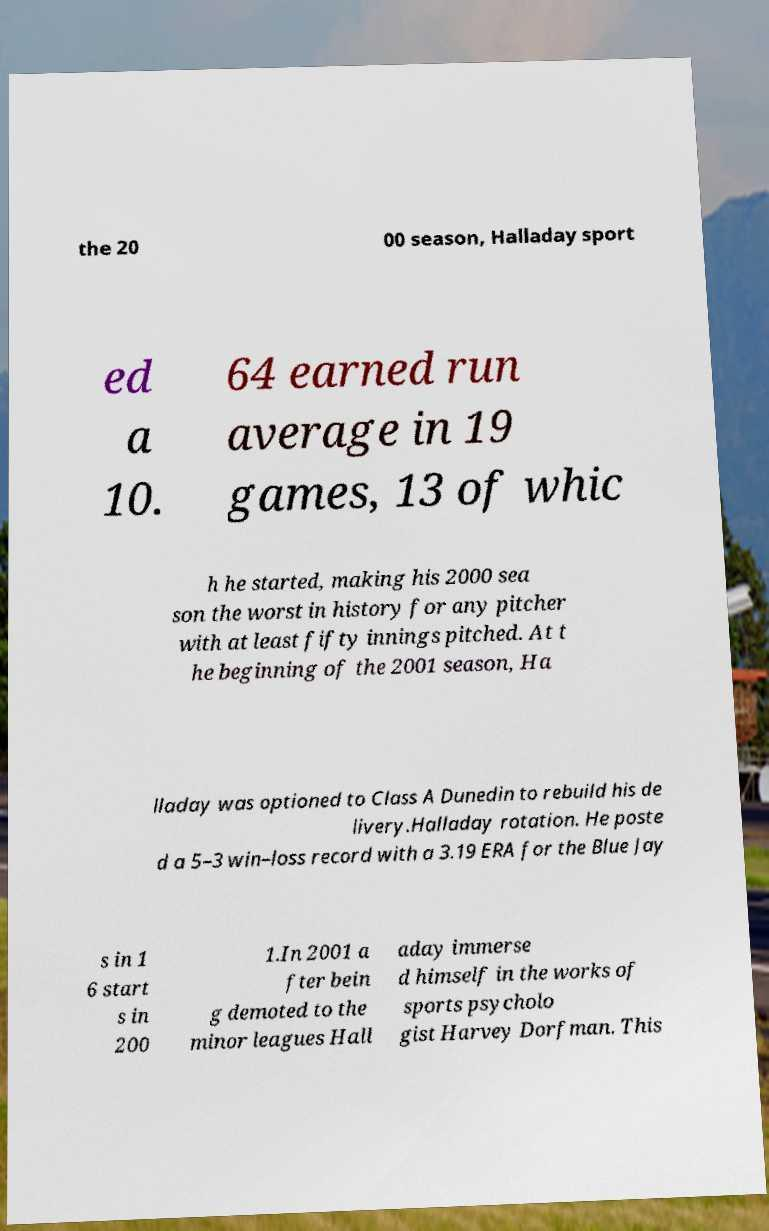Can you read and provide the text displayed in the image?This photo seems to have some interesting text. Can you extract and type it out for me? the 20 00 season, Halladay sport ed a 10. 64 earned run average in 19 games, 13 of whic h he started, making his 2000 sea son the worst in history for any pitcher with at least fifty innings pitched. At t he beginning of the 2001 season, Ha lladay was optioned to Class A Dunedin to rebuild his de livery.Halladay rotation. He poste d a 5–3 win–loss record with a 3.19 ERA for the Blue Jay s in 1 6 start s in 200 1.In 2001 a fter bein g demoted to the minor leagues Hall aday immerse d himself in the works of sports psycholo gist Harvey Dorfman. This 